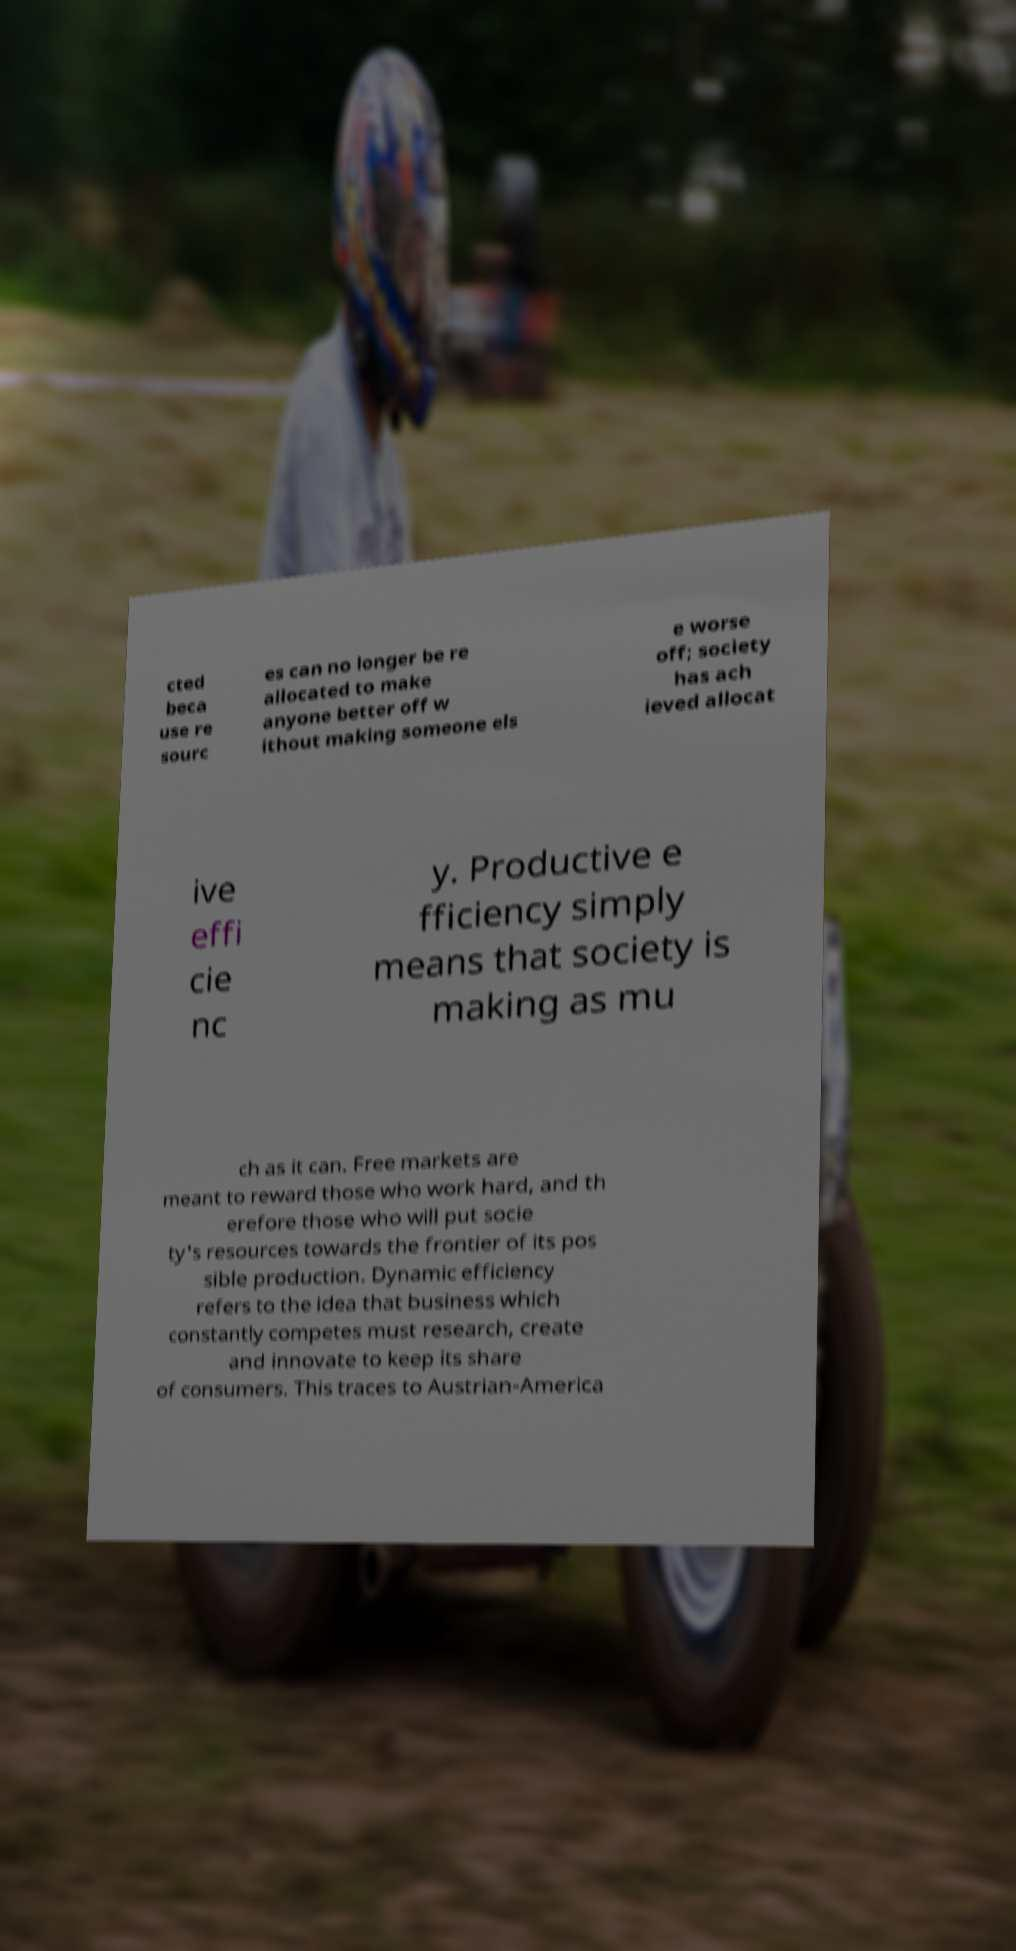Can you read and provide the text displayed in the image?This photo seems to have some interesting text. Can you extract and type it out for me? cted beca use re sourc es can no longer be re allocated to make anyone better off w ithout making someone els e worse off; society has ach ieved allocat ive effi cie nc y. Productive e fficiency simply means that society is making as mu ch as it can. Free markets are meant to reward those who work hard, and th erefore those who will put socie ty's resources towards the frontier of its pos sible production. Dynamic efficiency refers to the idea that business which constantly competes must research, create and innovate to keep its share of consumers. This traces to Austrian-America 